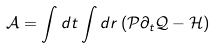Convert formula to latex. <formula><loc_0><loc_0><loc_500><loc_500>\mathcal { A } = \int d t \int d r \left ( \mathcal { P } \partial _ { t } \mathcal { Q } - \mathcal { H } \right )</formula> 